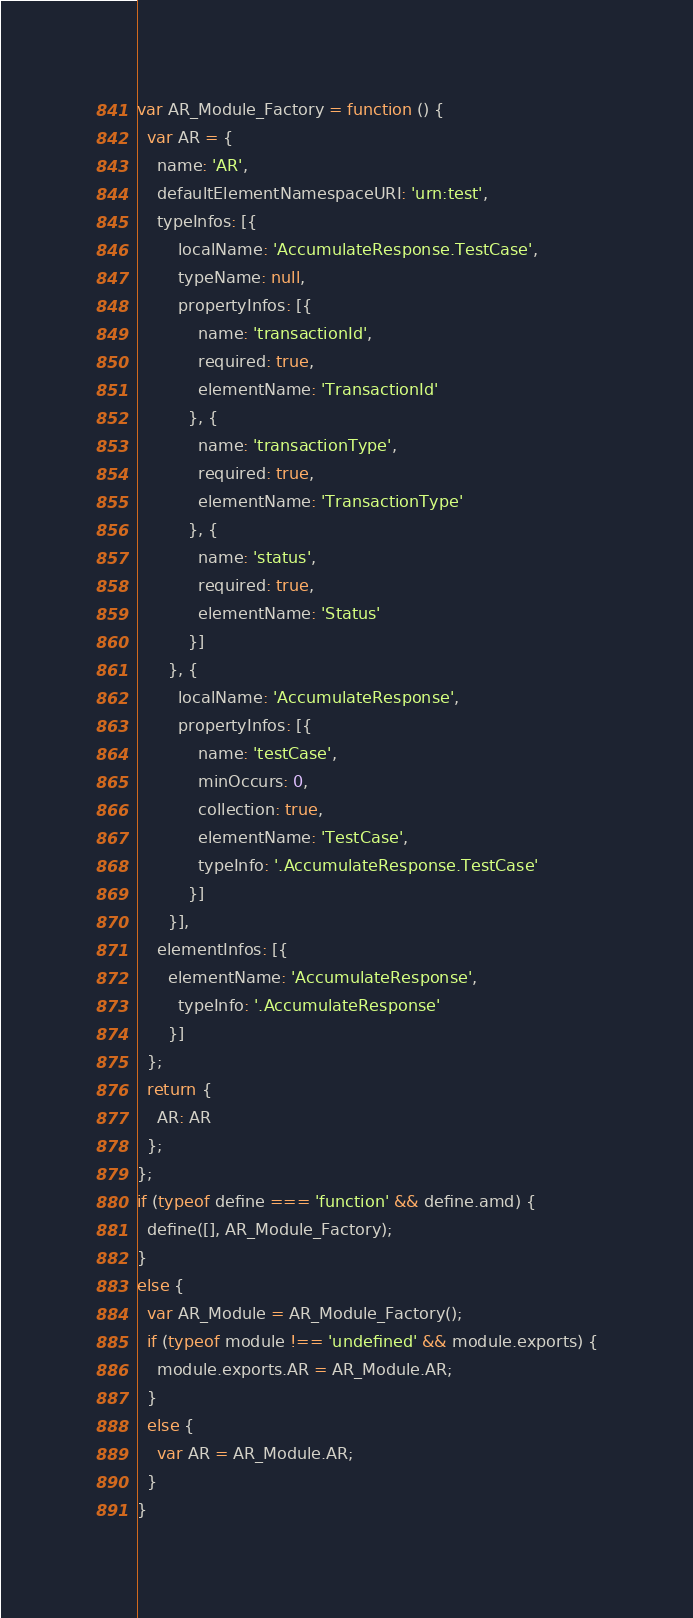<code> <loc_0><loc_0><loc_500><loc_500><_JavaScript_>var AR_Module_Factory = function () {
  var AR = {
    name: 'AR',
    defaultElementNamespaceURI: 'urn:test',
    typeInfos: [{
        localName: 'AccumulateResponse.TestCase',
        typeName: null,
        propertyInfos: [{
            name: 'transactionId',
            required: true,
            elementName: 'TransactionId'
          }, {
            name: 'transactionType',
            required: true,
            elementName: 'TransactionType'
          }, {
            name: 'status',
            required: true,
            elementName: 'Status'
          }]
      }, {
        localName: 'AccumulateResponse',
        propertyInfos: [{
            name: 'testCase',
            minOccurs: 0,
            collection: true,
            elementName: 'TestCase',
            typeInfo: '.AccumulateResponse.TestCase'
          }]
      }],
    elementInfos: [{
      elementName: 'AccumulateResponse',
        typeInfo: '.AccumulateResponse'
      }]
  };
  return {
    AR: AR
  };
};
if (typeof define === 'function' && define.amd) {
  define([], AR_Module_Factory);
}
else {
  var AR_Module = AR_Module_Factory();
  if (typeof module !== 'undefined' && module.exports) {
    module.exports.AR = AR_Module.AR;
  }
  else {
    var AR = AR_Module.AR;
  }
}</code> 